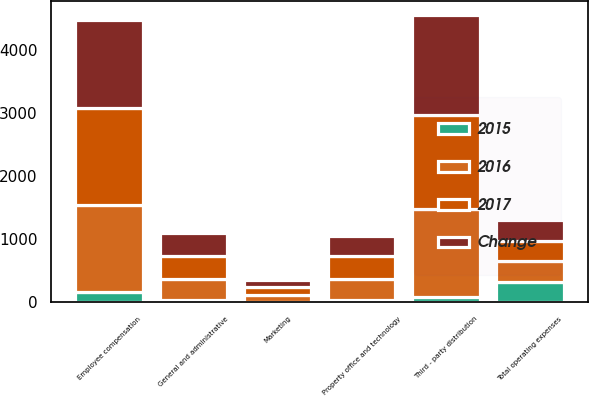Convert chart to OTSL. <chart><loc_0><loc_0><loc_500><loc_500><stacked_bar_chart><ecel><fcel>Third - party distribution<fcel>Employee compensation<fcel>Marketing<fcel>Property office and technology<fcel>General and administrative<fcel>Total operating expenses<nl><fcel>2017<fcel>1486.5<fcel>1537.4<fcel>123.7<fcel>370.1<fcel>365.5<fcel>325.7<nl><fcel>2016<fcel>1407.2<fcel>1378.8<fcel>114.8<fcel>325.7<fcel>331.5<fcel>325.7<nl><fcel>Change<fcel>1579.9<fcel>1395.5<fcel>115.4<fcel>312<fcel>361.7<fcel>325.7<nl><fcel>2015<fcel>79.3<fcel>158.6<fcel>8.9<fcel>44.4<fcel>34<fcel>325.2<nl></chart> 